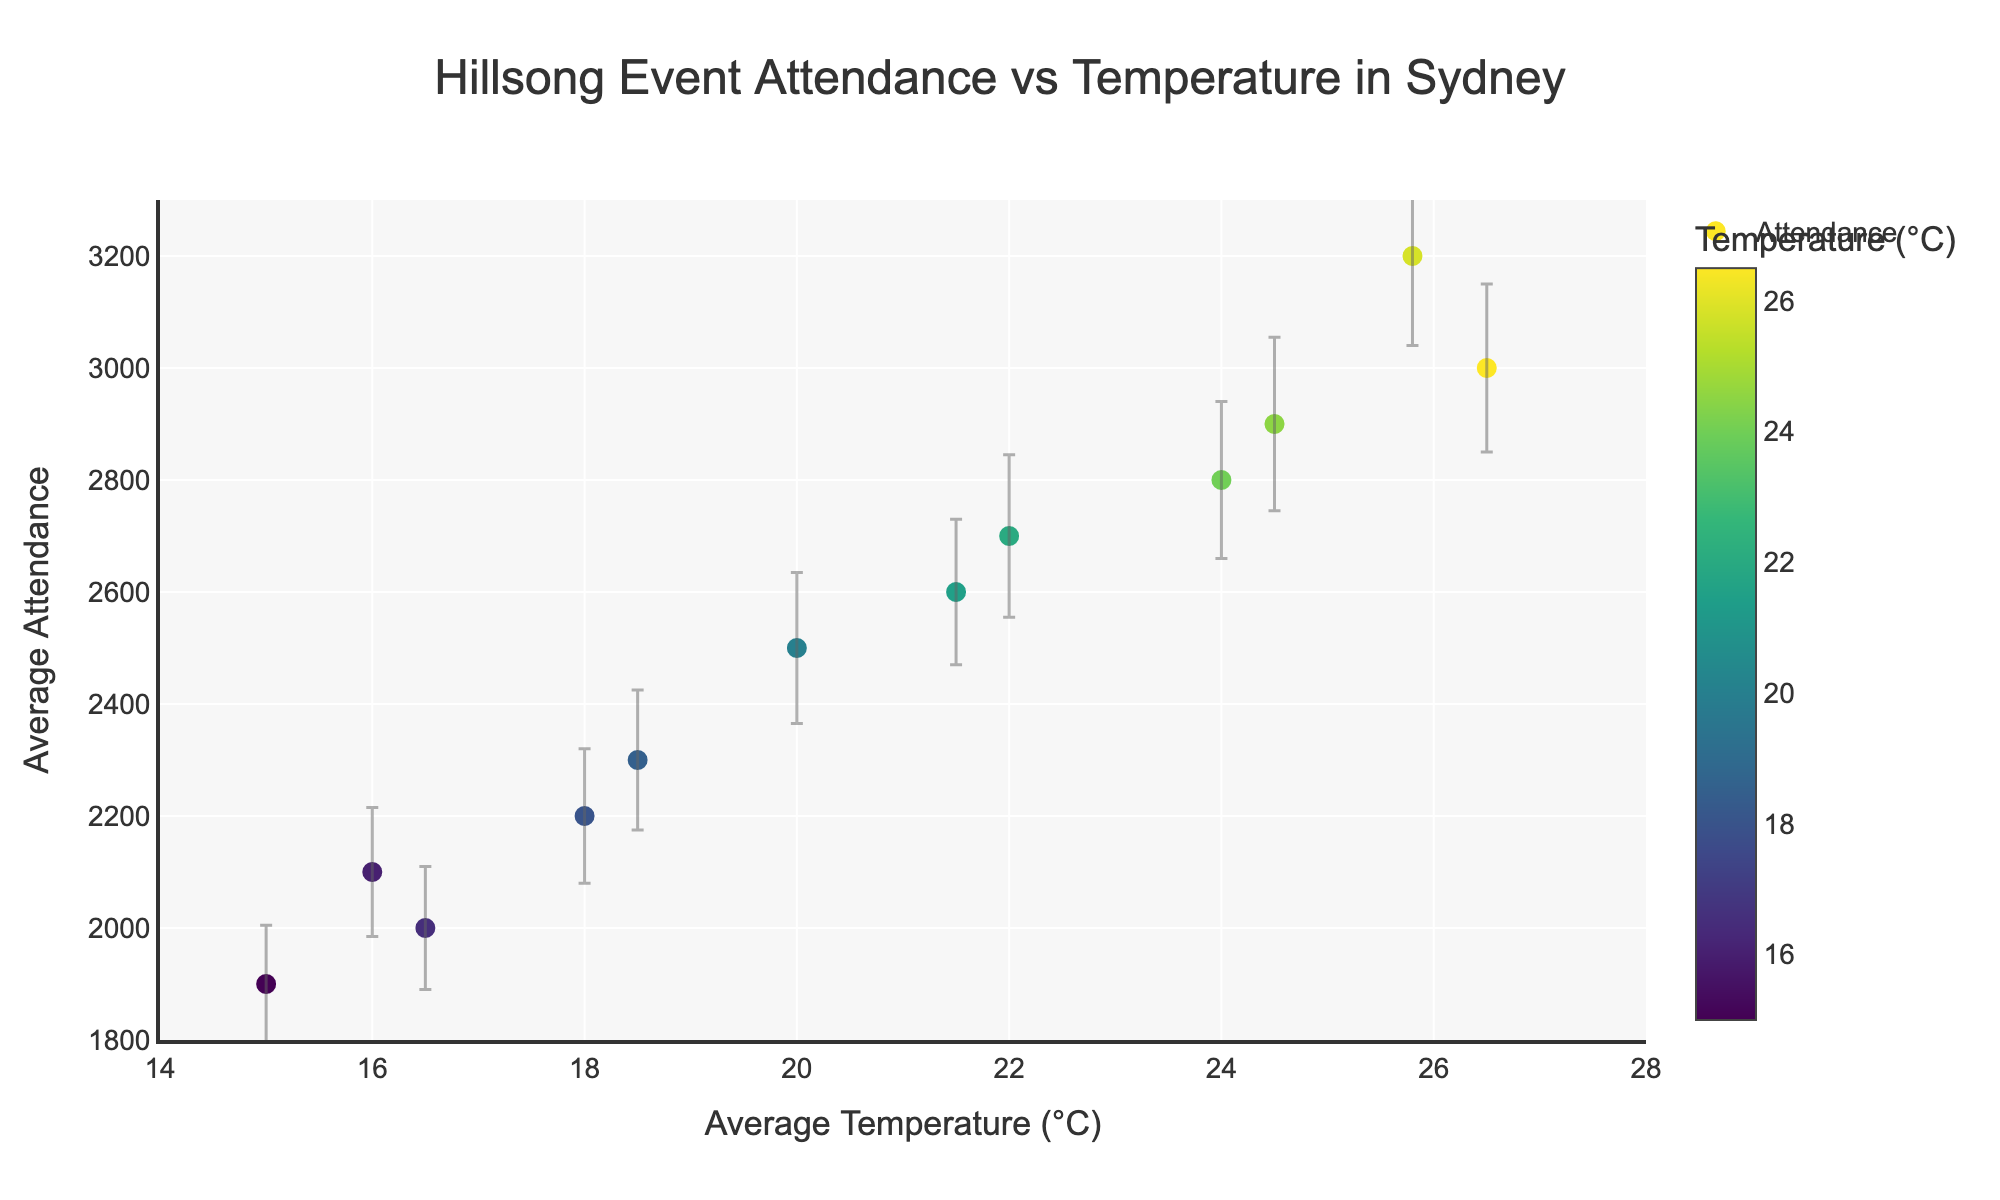how many data points are there in the scatter plot? To determine the number of data points, count the number of months listed in the dataset, as each month corresponds to a single data point.
Answer: 12 which month has the highest attendance? Look for the point on the scatter plot with the highest y-value, which represents attendance. The month with the highest y-value is the one with the highest attendance.
Answer: February what is the average attendance in months with temperatures above 20°C? Identify the data points where the temperature exceeds 20°C, then sum their attendance values and divide by the number of such months. (January, February, March, April, October, November, December)
Answer: (3000 + 3200 + 2800 + 2600 + 2500 + 2700 + 2900) / 7 = 2814.3 how does the attendance change from January to July? Compare the y-values of January and July. The attendance in January is 3000, and the attendance in July is 1900. Calculate the difference.
Answer: Attendance decreases by 1100 is there a clear trend between temperature and attendance? Observe the overall shape and direction of the data points. Generally, as temperature increases, attendance tends to be higher. However, variability exists, and the error bars should be considered.
Answer: Higher temperatures generally correlate with higher attendance, considering some variability what is the range of temperatures represented in the scatter plot? Determine the minimum and maximum x-values from the data points, which represent the range of temperatures.
Answer: 15°C to 26.5°C how do the error bars for attendance vary across different months? Examine the length of the error bars for each data point. Longer error bars indicate higher standard deviations and more variability in attendance. Shorter error bars indicate more consistent attendance.
Answer: The error bars range from 105 to 160, showing varying levels of attendance consistency which event type has the most consistent attendance? Identify the event type with the shortest average error bars, indicating the least variability in attendance.
Answer: Hillsong Worship Night which month has the lowest temperature? Find the data point with the lowest x-value, which corresponds to the month with the lowest temperature.
Answer: July what is the overall relationship between the temperature and the standard deviation of attendance? Assess if there's any visible pattern between the temperature (x-value) and the length of the error bars (which represent the standard deviation of attendance). If a trend exists, describe it.
Answer: No clear trend, the variability in attendance does not consistently increase or decrease with temperature 